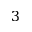Convert formula to latex. <formula><loc_0><loc_0><loc_500><loc_500>3</formula> 